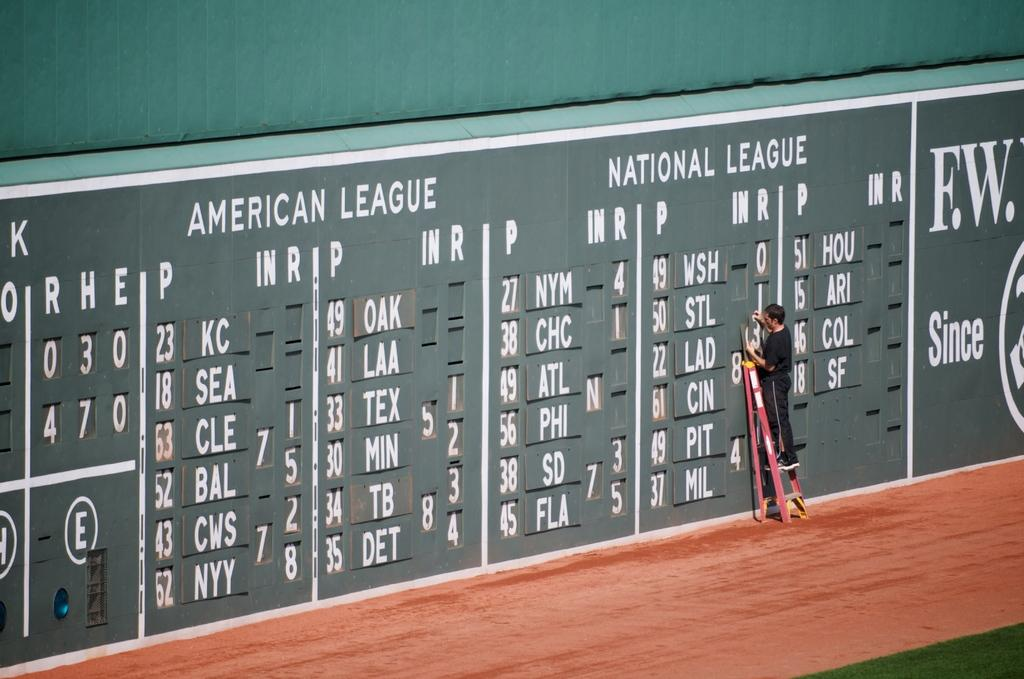<image>
Give a short and clear explanation of the subsequent image. A man changes out the numbers on board that tracks the win rates of teams in the National League. 